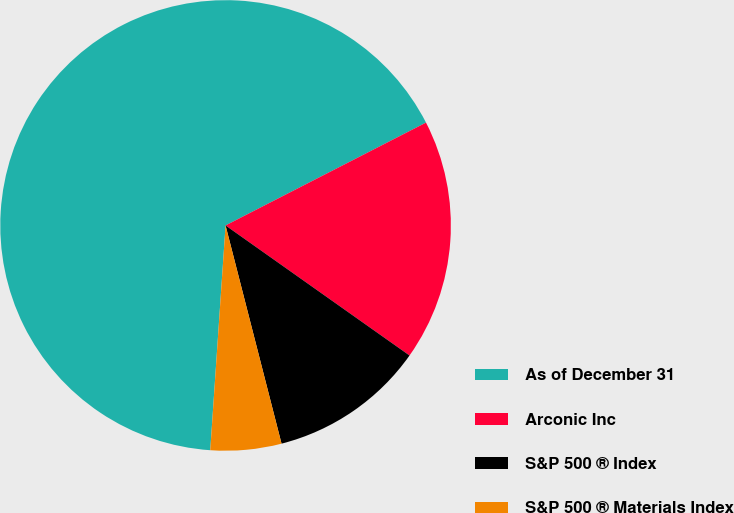Convert chart to OTSL. <chart><loc_0><loc_0><loc_500><loc_500><pie_chart><fcel>As of December 31<fcel>Arconic Inc<fcel>S&P 500 ® Index<fcel>S&P 500 ® Materials Index<nl><fcel>66.38%<fcel>17.34%<fcel>11.21%<fcel>5.08%<nl></chart> 